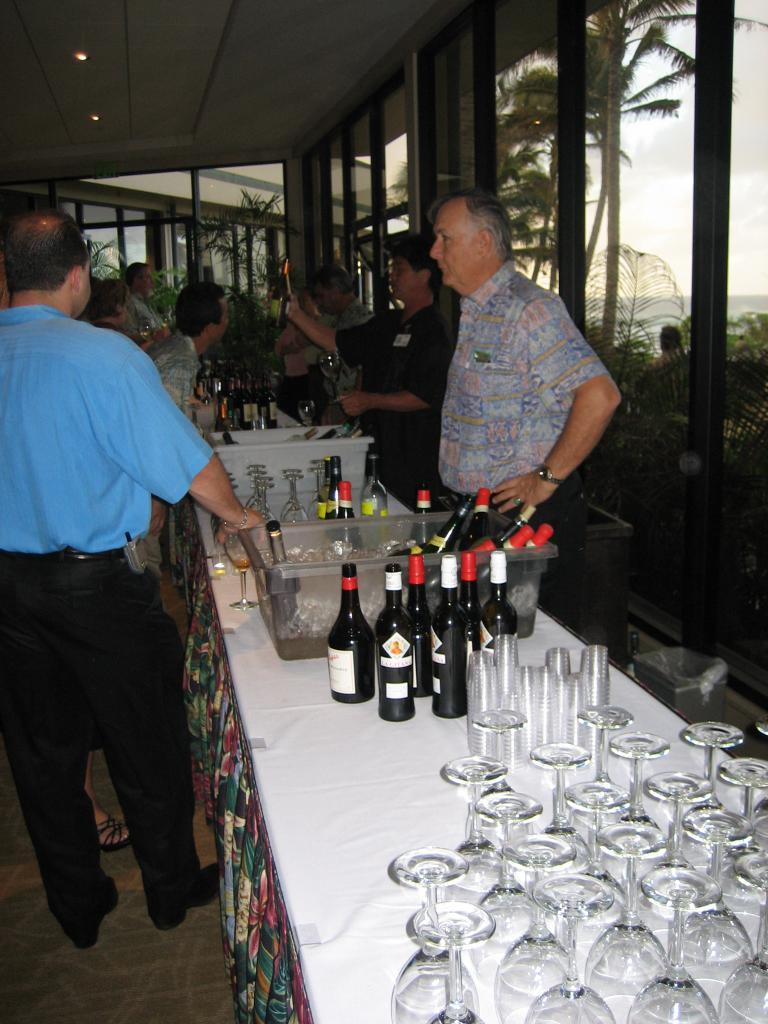How many people are in the image? There is a group of people standing in the image. What is present on the table in the image? There are bottles and glasses on the table in the image. What can be seen in the background of the image? There are trees in the background of the image. Where is the lock located in the image? There is no lock present in the image. What type of fruit is on the table in the image? The image does not show any fruit on the table, only bottles and glasses. 